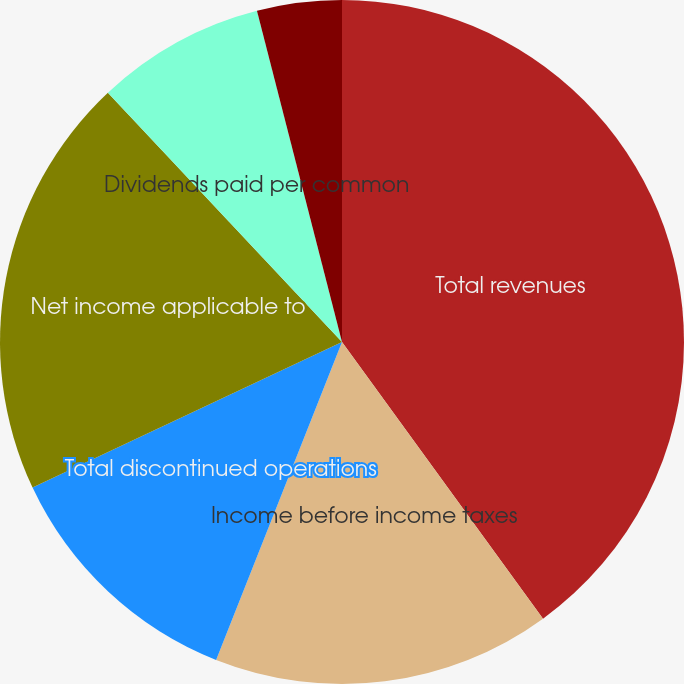Convert chart. <chart><loc_0><loc_0><loc_500><loc_500><pie_chart><fcel>Total revenues<fcel>Income before income taxes<fcel>Total discontinued operations<fcel>Net income applicable to<fcel>Dividends paid per common<fcel>Basic earnings per common<fcel>Diluted earnings per common<nl><fcel>40.0%<fcel>16.0%<fcel>12.0%<fcel>20.0%<fcel>8.0%<fcel>0.0%<fcel>4.0%<nl></chart> 